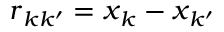Convert formula to latex. <formula><loc_0><loc_0><loc_500><loc_500>r _ { k k ^ { \prime } } = x _ { k } - x _ { k ^ { \prime } }</formula> 